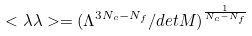Convert formula to latex. <formula><loc_0><loc_0><loc_500><loc_500>< \lambda \lambda > = ( \Lambda ^ { 3 N _ { c } - N _ { f } } / d e t M ) ^ { \frac { 1 } { N _ { c } - N _ { f } } }</formula> 